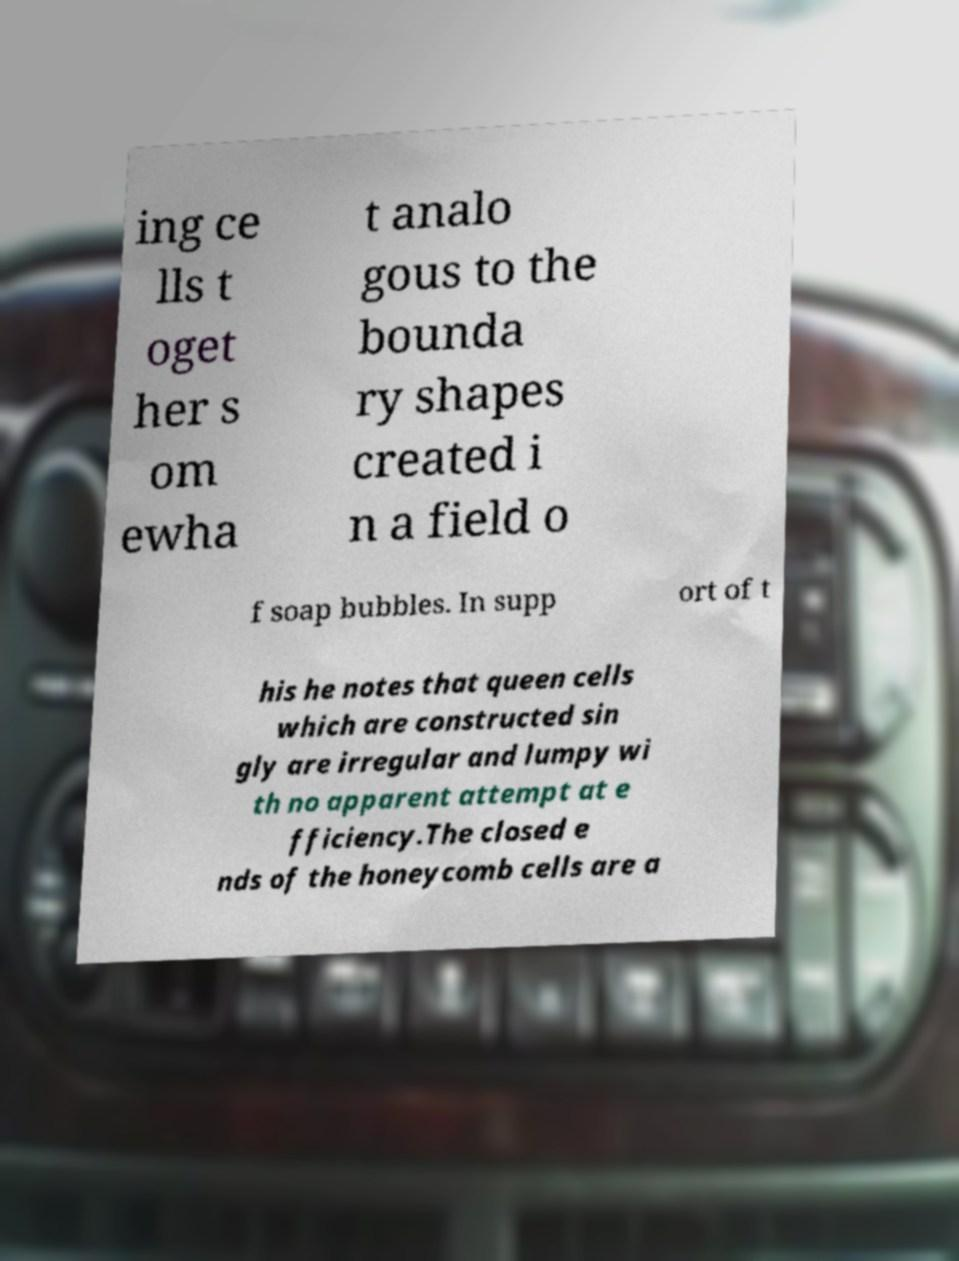Can you read and provide the text displayed in the image? This photo seems to have some interesting text. Can you extract and type it out for me? The visible text in the image is partially cut off, but here is the complete section that can be seen: 

"...bringing cells together somewhat analogous to the boundary shapes created in a field of soap bubbles. In support of this he notes that queen cells which are constructed singly are irregular and lumpy with no apparent attempt at efficiency. The closed ends of the honeycomb cells are a..." 